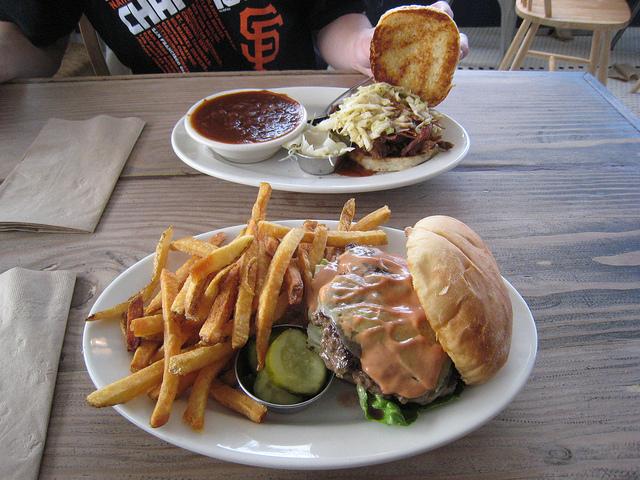Is that an egg ham sandwich?
Quick response, please. No. What is in the silver ramekin?
Answer briefly. Pickles. Is there any ketchup on the burger?
Short answer required. No. Does this appear to be a traditional breakfast or lunch meal?
Be succinct. Lunch. 